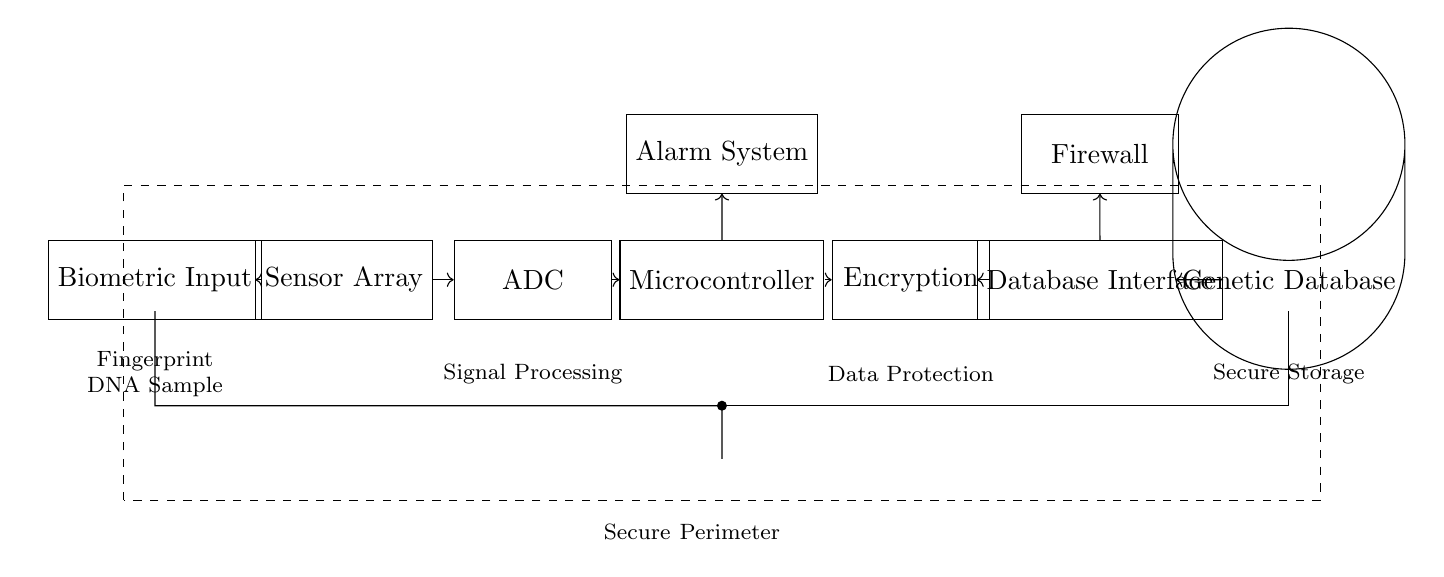What is the first component shown in the circuit? The first component in the circuit diagram is labeled "Biometric Input", which is positioned on the far left.
Answer: Biometric Input How many processing stages are there in this circuit before reaching the database? The circuit has a total of five processing stages: Biometric Input, Sensor Array, ADC, Microcontroller, and Encryption, leading to the Database Interface.
Answer: Five What is the function of the Alarm System in this circuit? The Alarm System is connected to the Microcontroller, indicating it likely serves as a warning mechanism in case of unauthorized access or system failure.
Answer: Warning mechanism Which component directly interfaces with the Genetic Database? The Database Interface is the component that directly connects to the Genetic Database, allowing access to the stored information.
Answer: Database Interface Why is there a firewall included in the circuit? The firewall is placed after the Database Interface, indicating it is utilized to protect the genetic information against external threats such as hacking or unauthorized access.
Answer: Protect genetic information What is the role of the ADC in the circuit? The ADC (Analog-to-Digital Converter) converts the analog signals from the Sensor Array into digital data for processing by the Microcontroller.
Answer: Convert analog to digital What emphasizes the secure aspect of this biometric security system? The dashed rectangle labeled "Secure Perimeter" surrounds the entire circuit, indicating the importance of physical and operational security measures in protecting genetic information.
Answer: Secure Perimeter 